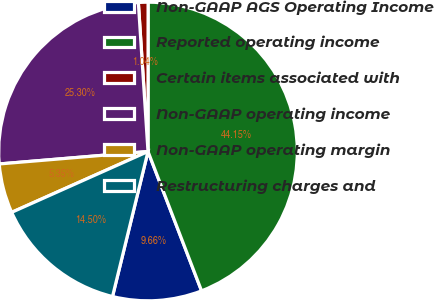<chart> <loc_0><loc_0><loc_500><loc_500><pie_chart><fcel>Non-GAAP AGS Operating Income<fcel>Reported operating income<fcel>Certain items associated with<fcel>Non-GAAP operating income<fcel>Non-GAAP operating margin<fcel>Restructuring charges and<nl><fcel>9.66%<fcel>44.15%<fcel>1.04%<fcel>25.3%<fcel>5.35%<fcel>14.5%<nl></chart> 